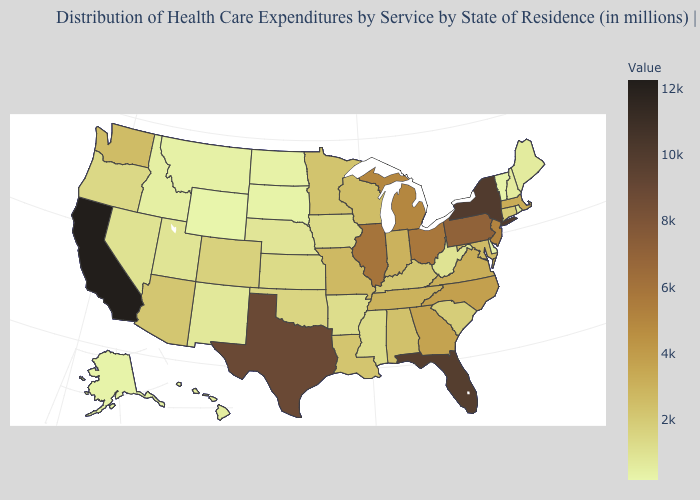Among the states that border Ohio , which have the highest value?
Be succinct. Pennsylvania. Does Wyoming have a lower value than Colorado?
Keep it brief. Yes. Does Oklahoma have the lowest value in the South?
Short answer required. No. Which states have the lowest value in the MidWest?
Short answer required. South Dakota. Which states hav the highest value in the South?
Keep it brief. Florida. Is the legend a continuous bar?
Concise answer only. Yes. Which states have the lowest value in the South?
Short answer required. Delaware. Among the states that border Arizona , which have the highest value?
Concise answer only. California. 